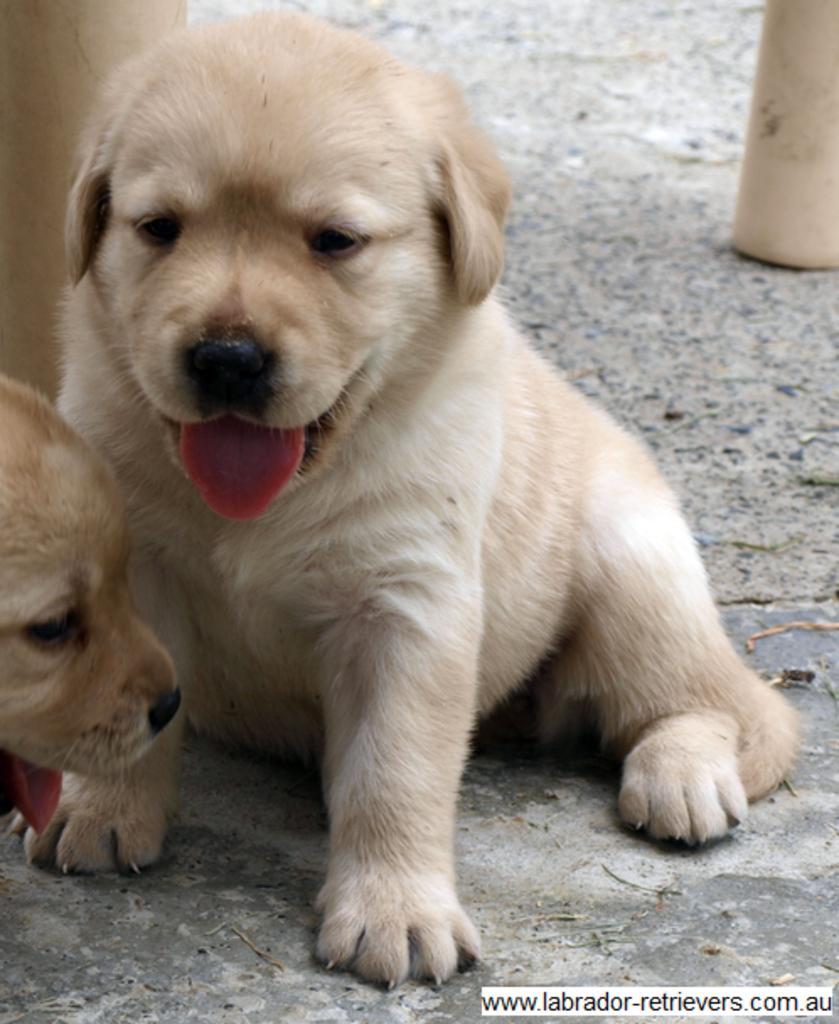Please provide a concise description of this image. In this picture we can see dogs. In the background of the image we can see objects. In the bottom right side of the image we can see text. 